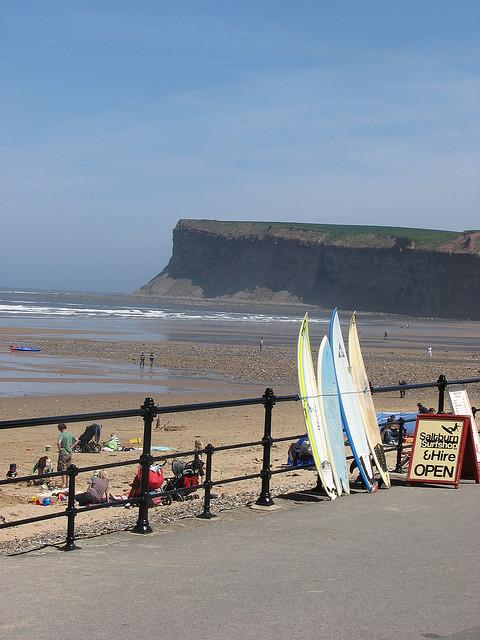What would you do with these boards?
Give a very brief answer. Surf. What on the sign starts with an O?
Give a very brief answer. Open. How many boards are lined up?
Short answer required. 4. 